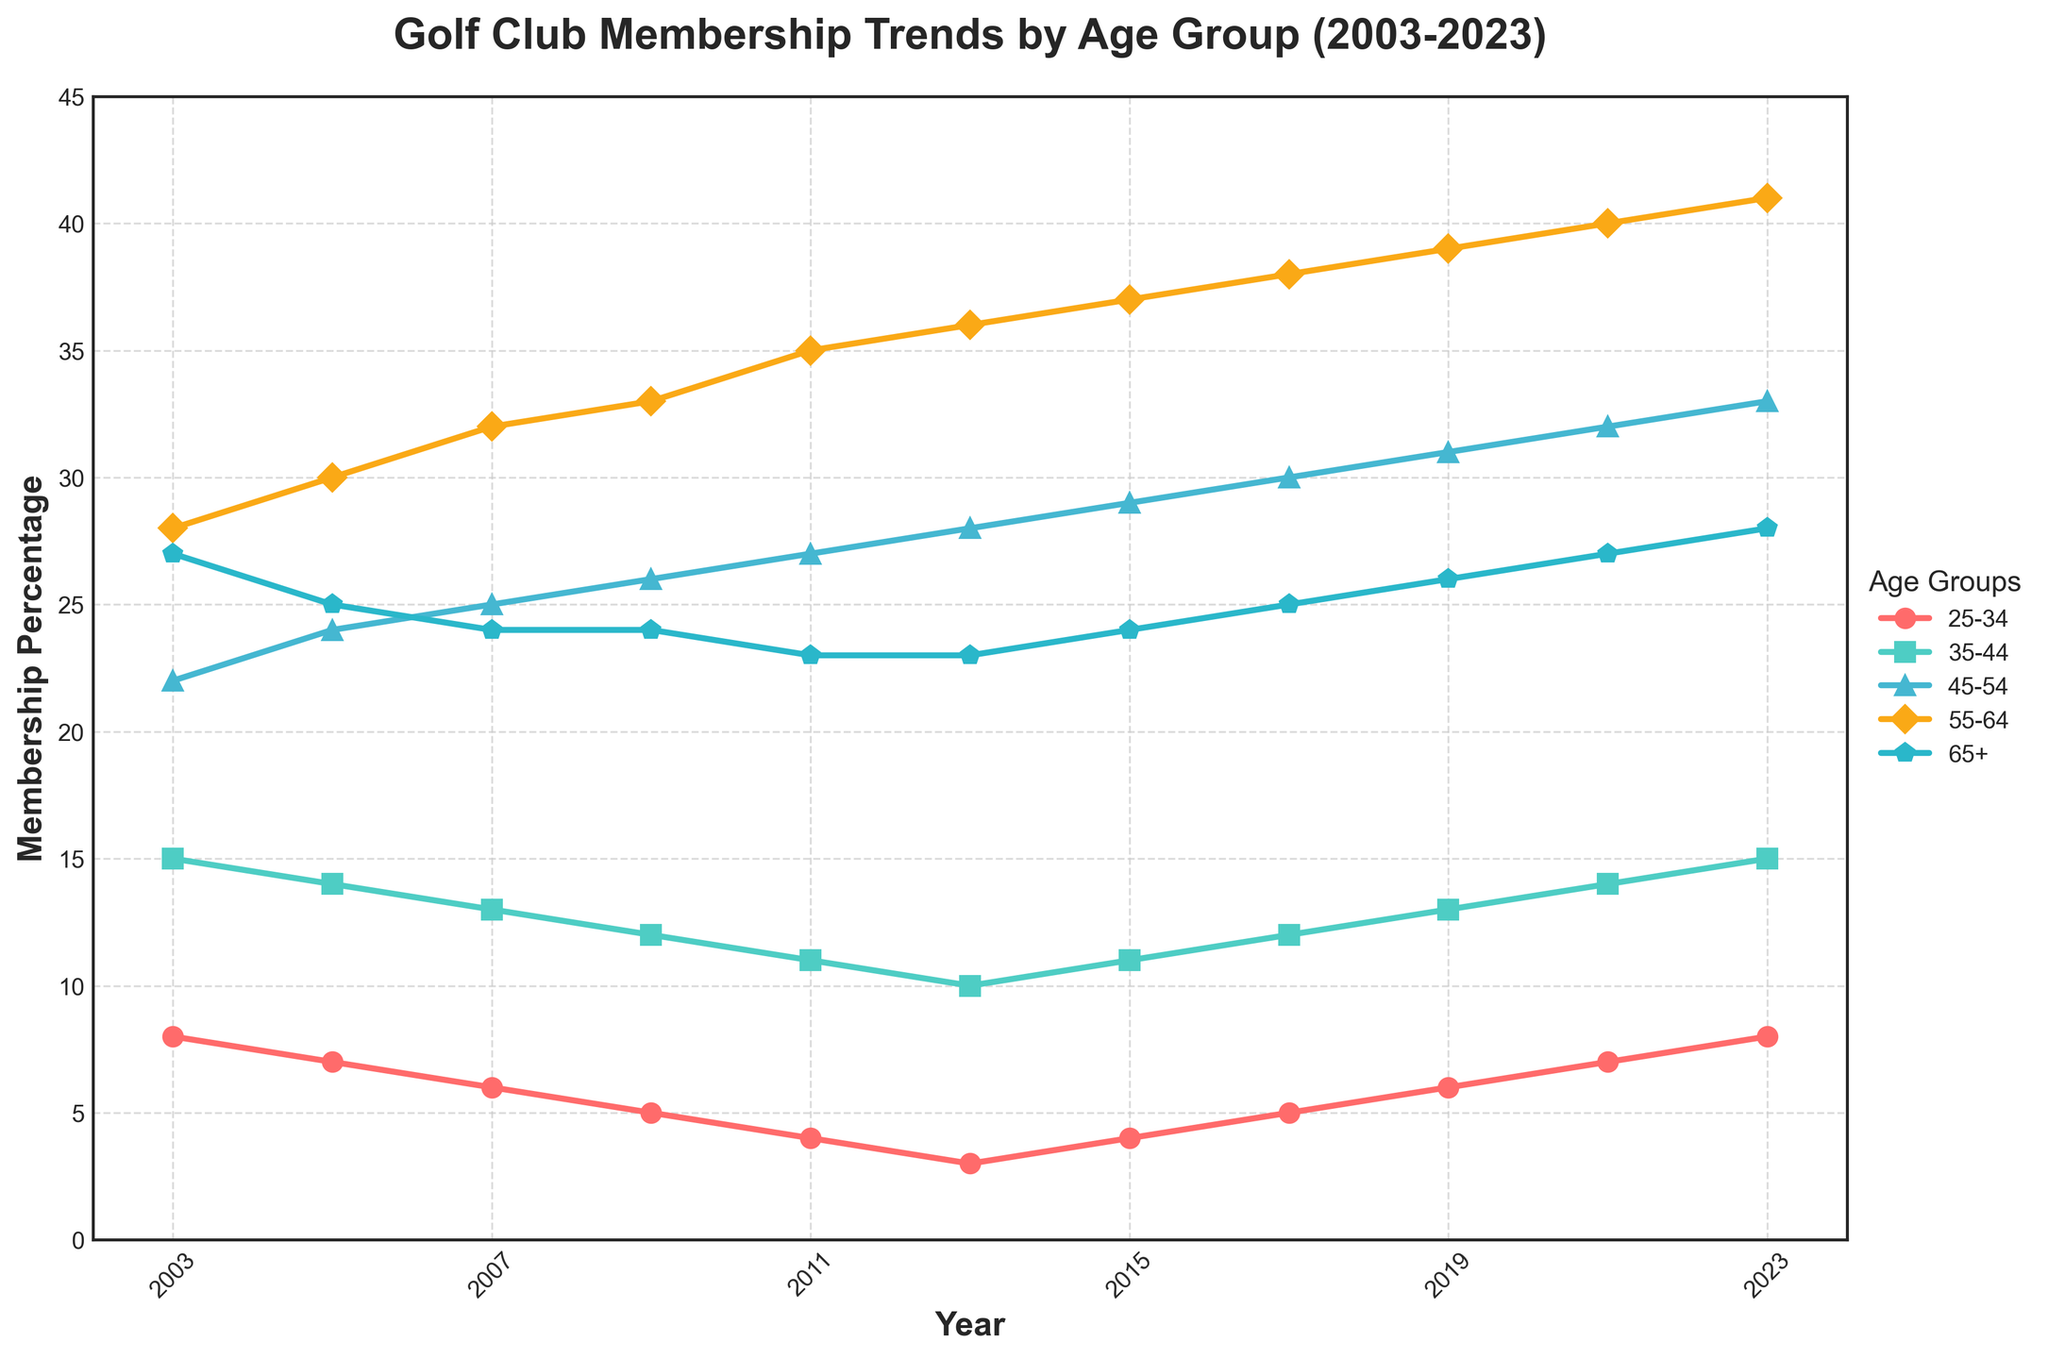When did the age group 25-34 have the lowest membership percentage? The line for the 25-34 age group reaches its lowest point in 2013. Looking at the y-axis, the value here is 3%
Answer: 2013 Which age group had the highest membership percentage in 2023? In 2023, the line representing the 55-64 age group reaches the highest point on the y-axis.
Answer: 55-64 Compare the membership trends for the age groups 35-44 and 45-54 over these 20 years. Which group shows a higher value in 2021? In 2021, the red line for 35-44 and the green line for 45-54. The green line (45-54) is at 32%, while the red line (35-44) is at 14%.
Answer: 45-54 Calculate the average membership percentage for the 55-64 age group over the 20 years. Sum the percentages for the 55-64 age group: 28+30+32+33+35+36+37+38+39+40+41=389. Divide by 11 (the number of data points): 389/11 ≈ 35.36
Answer: 35.36 What is the difference in total membership percentages between the 25-34 and 65+ age groups in 2023? The 25-34 age group is at 8%, and the 65+ age group is at 28% in 2023. The difference is 28% - 8% = 20%.
Answer: 20% Which age group shows the least change in membership percentage over the entire period? The purple line for the 65+ age group has the least vertical movement, indicating less change. The percentages only vary from 27% to 23%.
Answer: 65+ By how much did the membership percentage for the age group 45-54 increase from 2003 to 2023? The membership percentage for the 45-54 age group was 22% in 2003 and increased to 33% in 2023. The difference is 33% - 22% = 11%.
Answer: 11% In which year did the 35-44 and 45-54 age groups have equal membership percentages? The red (35-44) and green (45-54) lines intersect in the graph for just 2003 and 2023.
Answer: 2003, 2023 Which age group surpassed the 30% membership mark first, and in which year? The green line for the 45-54 age group surpasses the 30% mark first in 2005.
Answer: 45-54, 2005 